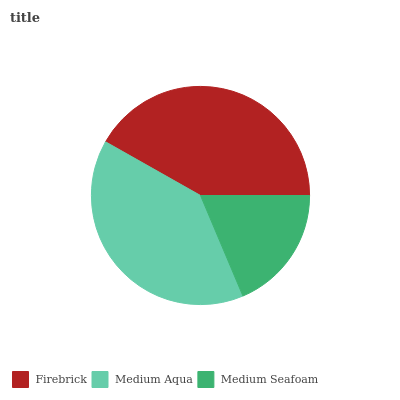Is Medium Seafoam the minimum?
Answer yes or no. Yes. Is Firebrick the maximum?
Answer yes or no. Yes. Is Medium Aqua the minimum?
Answer yes or no. No. Is Medium Aqua the maximum?
Answer yes or no. No. Is Firebrick greater than Medium Aqua?
Answer yes or no. Yes. Is Medium Aqua less than Firebrick?
Answer yes or no. Yes. Is Medium Aqua greater than Firebrick?
Answer yes or no. No. Is Firebrick less than Medium Aqua?
Answer yes or no. No. Is Medium Aqua the high median?
Answer yes or no. Yes. Is Medium Aqua the low median?
Answer yes or no. Yes. Is Firebrick the high median?
Answer yes or no. No. Is Firebrick the low median?
Answer yes or no. No. 